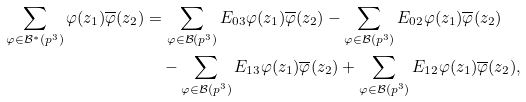<formula> <loc_0><loc_0><loc_500><loc_500>\sum _ { \varphi \in \mathcal { B } ^ { * } ( p ^ { 3 } ) } \varphi ( z _ { 1 } ) \overline { \varphi } ( z _ { 2 } ) & = \sum _ { \varphi \in \mathcal { B } ( p ^ { 3 } ) } E _ { 0 3 } \varphi ( z _ { 1 } ) \overline { \varphi } ( z _ { 2 } ) - \sum _ { \varphi \in \mathcal { B } ( p ^ { 3 } ) } E _ { 0 2 } \varphi ( z _ { 1 } ) \overline { \varphi } ( z _ { 2 } ) \\ & \quad - \sum _ { \varphi \in \mathcal { B } ( p ^ { 3 } ) } E _ { 1 3 } \varphi ( z _ { 1 } ) \overline { \varphi } ( z _ { 2 } ) + \sum _ { \varphi \in \mathcal { B } ( p ^ { 3 } ) } E _ { 1 2 } \varphi ( z _ { 1 } ) \overline { \varphi } ( z _ { 2 } ) ,</formula> 